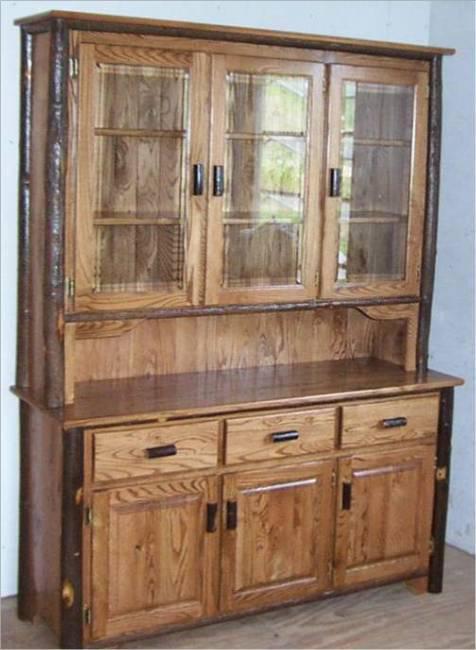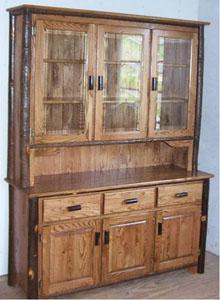The first image is the image on the left, the second image is the image on the right. Assess this claim about the two images: "All images show a piece of furniture with drawers". Correct or not? Answer yes or no. Yes. 